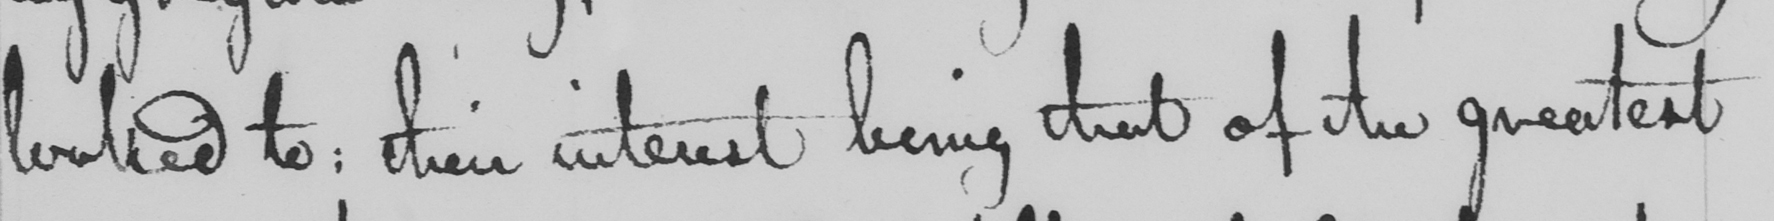What does this handwritten line say? looked to :  their interest being that of the greatest 